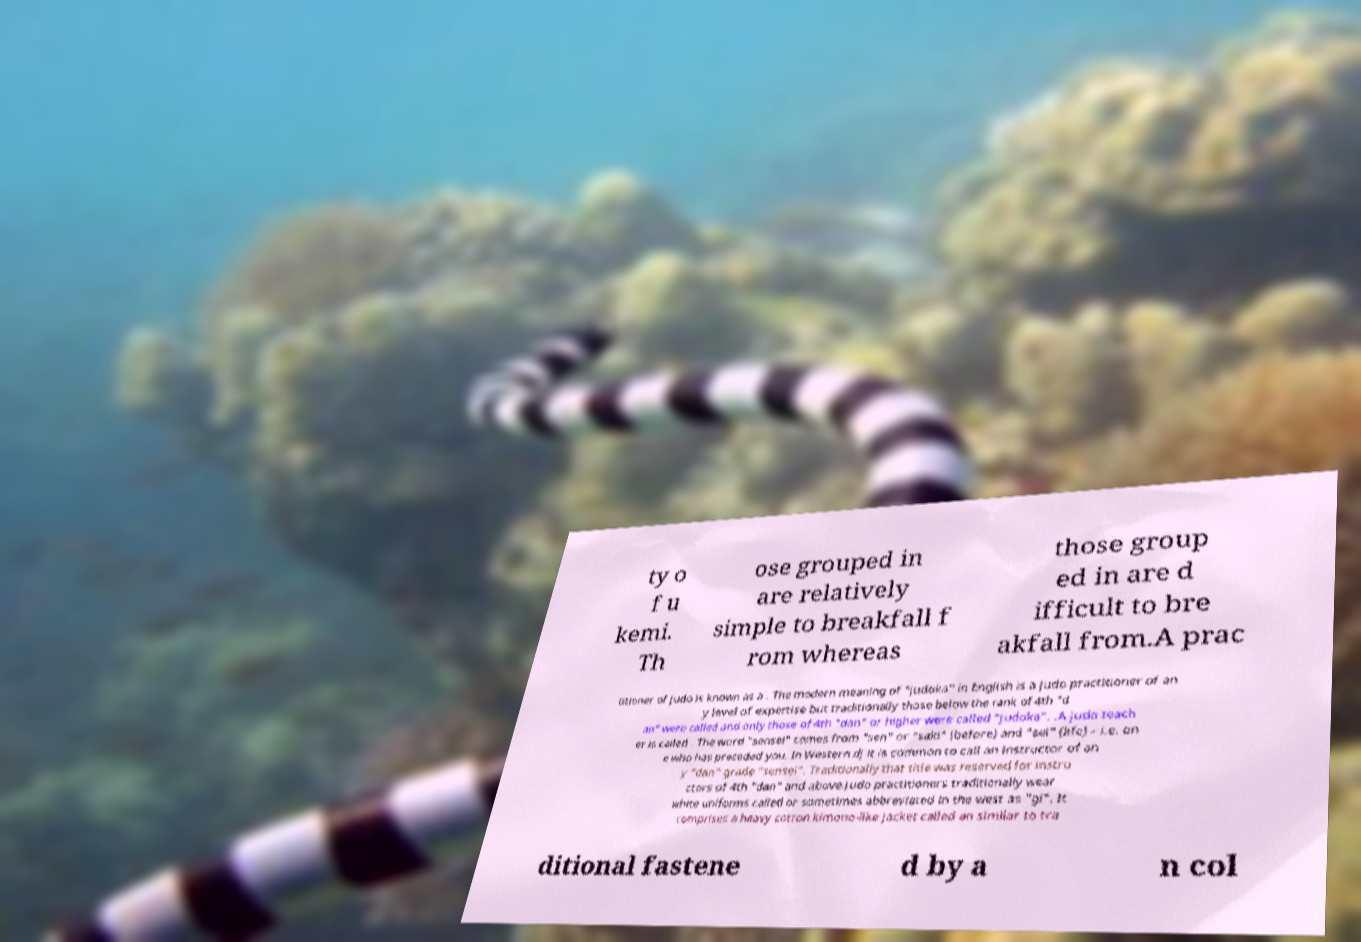For documentation purposes, I need the text within this image transcribed. Could you provide that? ty o f u kemi. Th ose grouped in are relatively simple to breakfall f rom whereas those group ed in are d ifficult to bre akfall from.A prac titioner of judo is known as a . The modern meaning of "judoka" in English is a judo practitioner of an y level of expertise but traditionally those below the rank of 4th "d an" were called and only those of 4th "dan" or higher were called "judoka". .A judo teach er is called . The word "sensei" comes from "sen" or "saki" (before) and "sei" (life) – i.e. on e who has preceded you. In Western dj it is common to call an instructor of an y "dan" grade "sensei". Traditionally that title was reserved for instru ctors of 4th "dan" and above.Judo practitioners traditionally wear white uniforms called or sometimes abbreviated in the west as "gi". It comprises a heavy cotton kimono-like jacket called an similar to tra ditional fastene d by a n col 